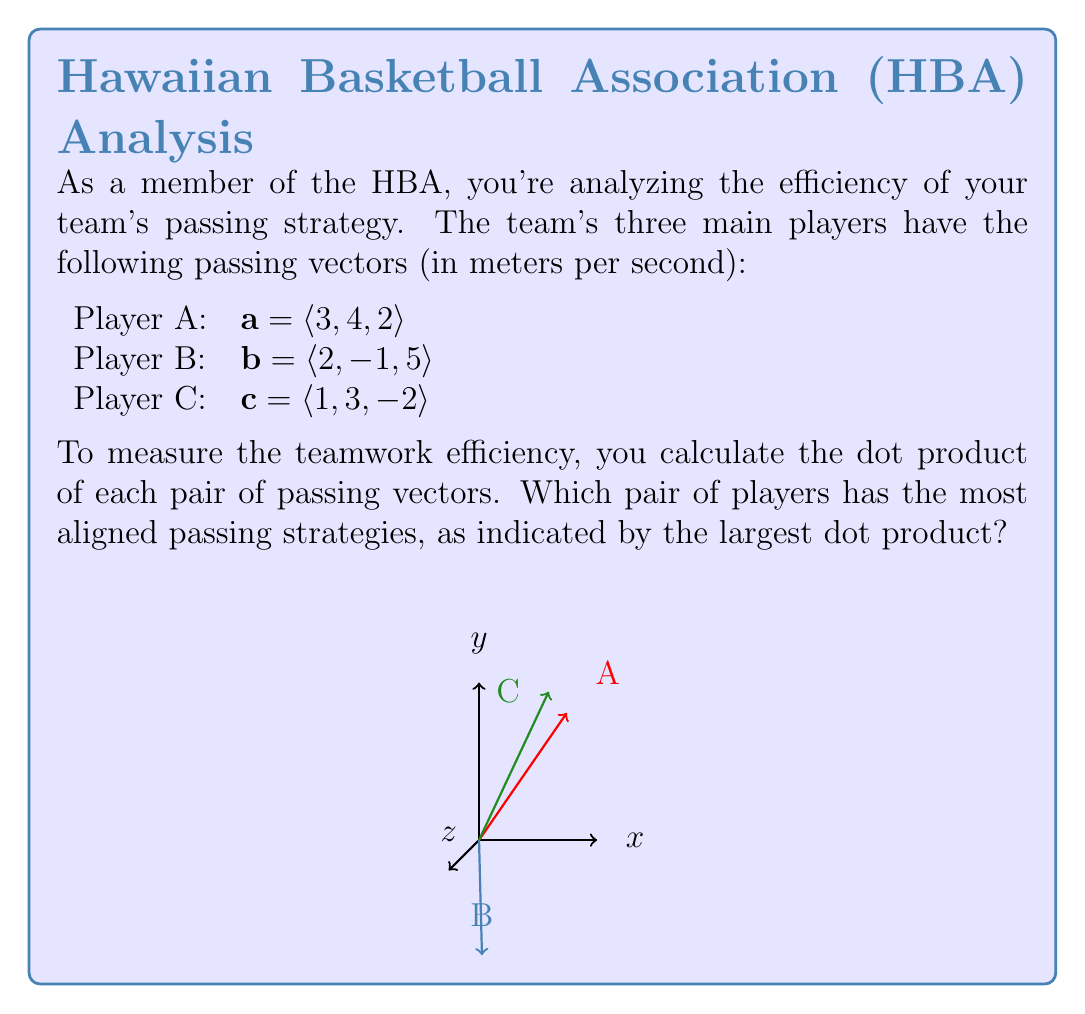Can you solve this math problem? To solve this problem, we need to calculate the dot product for each pair of players and compare the results. The dot product of two vectors $\mathbf{u} = \langle u_1, u_2, u_3 \rangle$ and $\mathbf{v} = \langle v_1, v_2, v_3 \rangle$ is given by:

$$\mathbf{u} \cdot \mathbf{v} = u_1v_1 + u_2v_2 + u_3v_3$$

Let's calculate the dot product for each pair:

1. Players A and B:
   $$\mathbf{a} \cdot \mathbf{b} = (3)(2) + (4)(-1) + (2)(5) = 6 - 4 + 10 = 12$$

2. Players A and C:
   $$\mathbf{a} \cdot \mathbf{c} = (3)(1) + (4)(3) + (2)(-2) = 3 + 12 - 4 = 11$$

3. Players B and C:
   $$\mathbf{b} \cdot \mathbf{c} = (2)(1) + (-1)(3) + (5)(-2) = 2 - 3 - 10 = -11$$

The largest dot product is 12, which corresponds to the pair of Players A and B. This indicates that their passing strategies are the most aligned among the three pairs.

It's worth noting that a larger dot product suggests that the vectors are more closely aligned in direction, which in this context implies better teamwork in terms of passing strategies.
Answer: Players A and B 